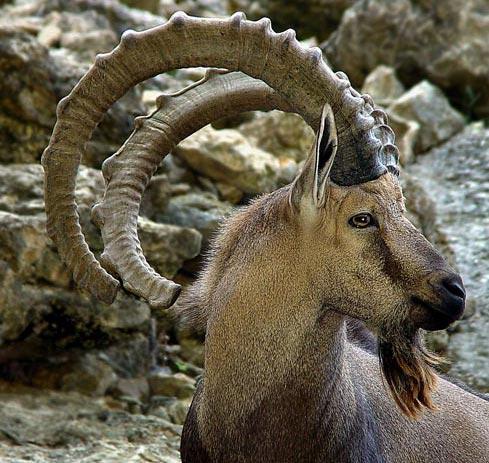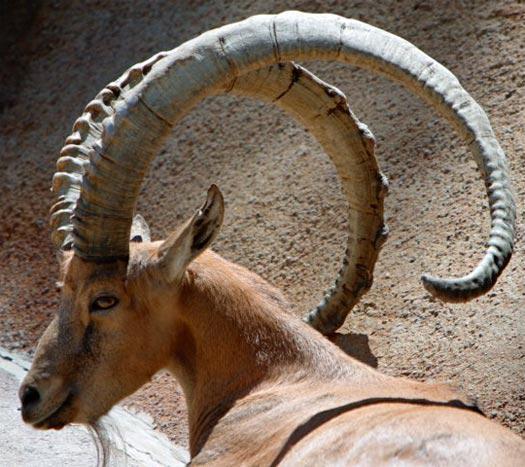The first image is the image on the left, the second image is the image on the right. Assess this claim about the two images: "In one image the tail of the mountain goat is visible.". Correct or not? Answer yes or no. No. 